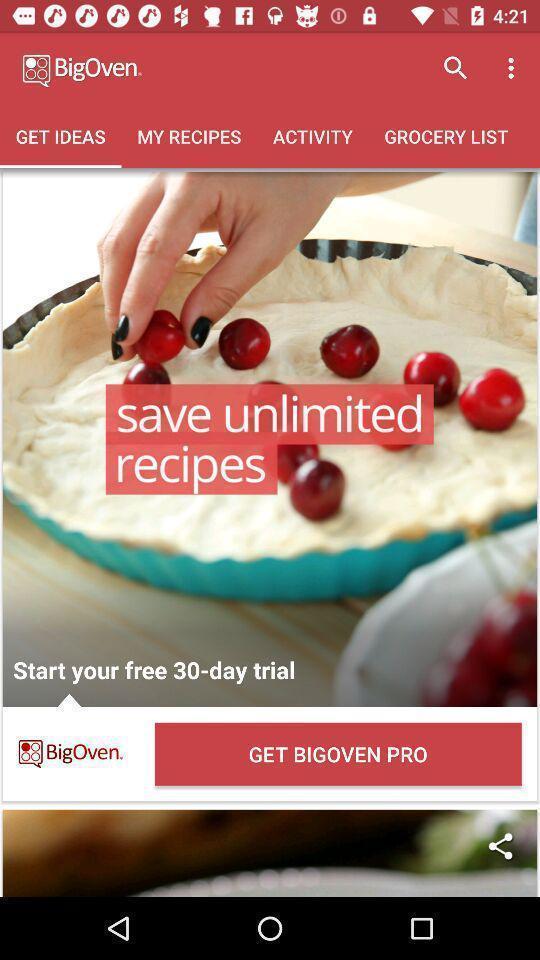Summarize the information in this screenshot. Page displaying the ideas for the dishes to try. 